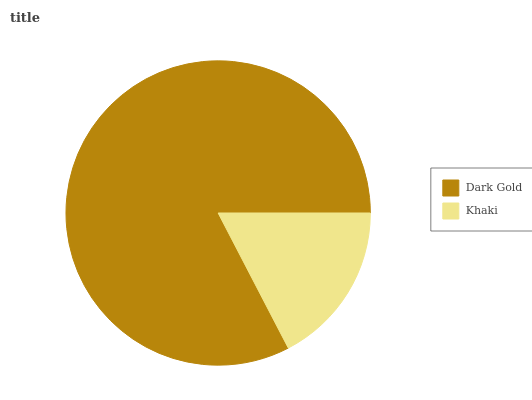Is Khaki the minimum?
Answer yes or no. Yes. Is Dark Gold the maximum?
Answer yes or no. Yes. Is Khaki the maximum?
Answer yes or no. No. Is Dark Gold greater than Khaki?
Answer yes or no. Yes. Is Khaki less than Dark Gold?
Answer yes or no. Yes. Is Khaki greater than Dark Gold?
Answer yes or no. No. Is Dark Gold less than Khaki?
Answer yes or no. No. Is Dark Gold the high median?
Answer yes or no. Yes. Is Khaki the low median?
Answer yes or no. Yes. Is Khaki the high median?
Answer yes or no. No. Is Dark Gold the low median?
Answer yes or no. No. 